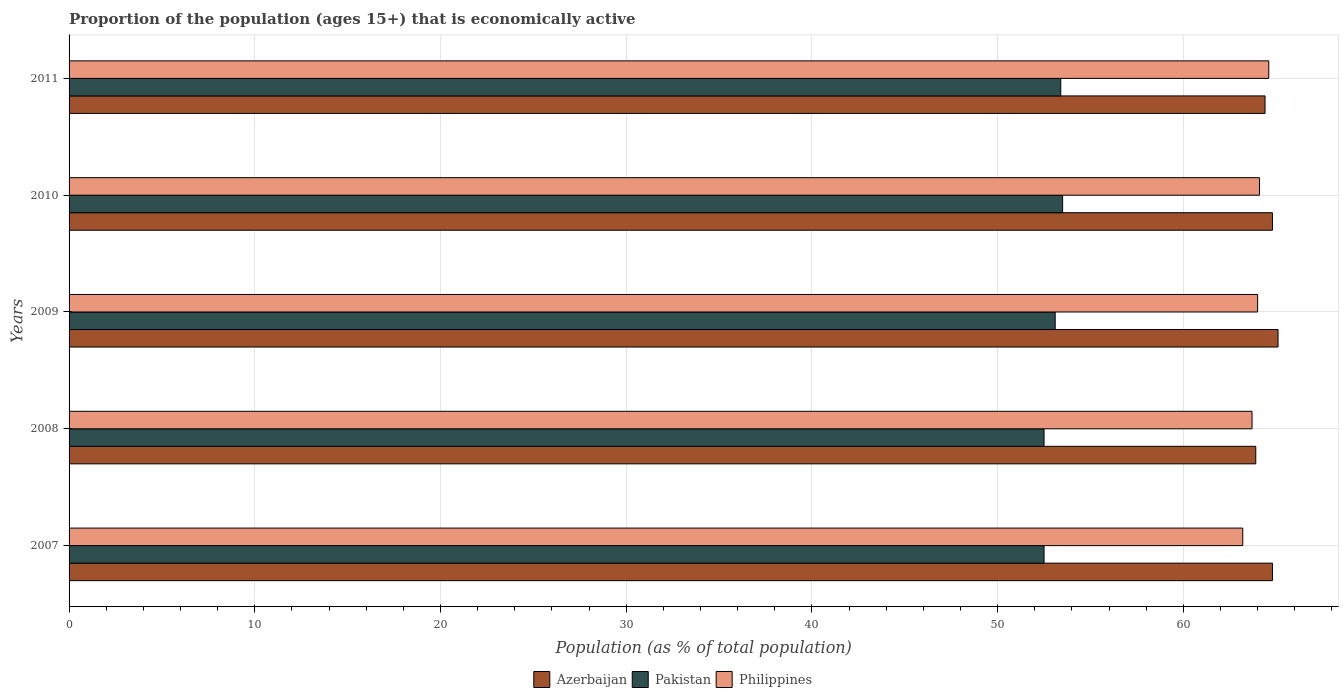How many bars are there on the 1st tick from the bottom?
Ensure brevity in your answer.  3. What is the label of the 3rd group of bars from the top?
Give a very brief answer. 2009. In how many cases, is the number of bars for a given year not equal to the number of legend labels?
Your response must be concise. 0. What is the proportion of the population that is economically active in Azerbaijan in 2009?
Offer a very short reply. 65.1. Across all years, what is the maximum proportion of the population that is economically active in Philippines?
Your response must be concise. 64.6. Across all years, what is the minimum proportion of the population that is economically active in Philippines?
Provide a succinct answer. 63.2. In which year was the proportion of the population that is economically active in Pakistan maximum?
Give a very brief answer. 2010. What is the total proportion of the population that is economically active in Philippines in the graph?
Offer a terse response. 319.6. What is the difference between the proportion of the population that is economically active in Azerbaijan in 2007 and that in 2008?
Offer a terse response. 0.9. What is the difference between the proportion of the population that is economically active in Pakistan in 2010 and the proportion of the population that is economically active in Azerbaijan in 2009?
Your answer should be very brief. -11.6. What is the average proportion of the population that is economically active in Azerbaijan per year?
Your answer should be very brief. 64.6. In the year 2011, what is the difference between the proportion of the population that is economically active in Philippines and proportion of the population that is economically active in Pakistan?
Make the answer very short. 11.2. What is the ratio of the proportion of the population that is economically active in Philippines in 2007 to that in 2008?
Your answer should be compact. 0.99. Is the difference between the proportion of the population that is economically active in Philippines in 2007 and 2008 greater than the difference between the proportion of the population that is economically active in Pakistan in 2007 and 2008?
Your response must be concise. No. What is the difference between the highest and the second highest proportion of the population that is economically active in Azerbaijan?
Your answer should be very brief. 0.3. What is the difference between the highest and the lowest proportion of the population that is economically active in Azerbaijan?
Your answer should be very brief. 1.2. Is the sum of the proportion of the population that is economically active in Azerbaijan in 2008 and 2009 greater than the maximum proportion of the population that is economically active in Philippines across all years?
Give a very brief answer. Yes. What does the 2nd bar from the bottom in 2009 represents?
Your response must be concise. Pakistan. Are all the bars in the graph horizontal?
Your answer should be very brief. Yes. How many years are there in the graph?
Your answer should be very brief. 5. How many legend labels are there?
Provide a succinct answer. 3. How are the legend labels stacked?
Provide a succinct answer. Horizontal. What is the title of the graph?
Provide a short and direct response. Proportion of the population (ages 15+) that is economically active. What is the label or title of the X-axis?
Provide a short and direct response. Population (as % of total population). What is the Population (as % of total population) of Azerbaijan in 2007?
Offer a very short reply. 64.8. What is the Population (as % of total population) of Pakistan in 2007?
Your answer should be very brief. 52.5. What is the Population (as % of total population) in Philippines in 2007?
Your answer should be very brief. 63.2. What is the Population (as % of total population) of Azerbaijan in 2008?
Provide a succinct answer. 63.9. What is the Population (as % of total population) in Pakistan in 2008?
Provide a succinct answer. 52.5. What is the Population (as % of total population) in Philippines in 2008?
Provide a succinct answer. 63.7. What is the Population (as % of total population) in Azerbaijan in 2009?
Your response must be concise. 65.1. What is the Population (as % of total population) in Pakistan in 2009?
Provide a short and direct response. 53.1. What is the Population (as % of total population) in Azerbaijan in 2010?
Offer a terse response. 64.8. What is the Population (as % of total population) of Pakistan in 2010?
Ensure brevity in your answer.  53.5. What is the Population (as % of total population) in Philippines in 2010?
Offer a terse response. 64.1. What is the Population (as % of total population) in Azerbaijan in 2011?
Your answer should be compact. 64.4. What is the Population (as % of total population) in Pakistan in 2011?
Your answer should be compact. 53.4. What is the Population (as % of total population) of Philippines in 2011?
Provide a succinct answer. 64.6. Across all years, what is the maximum Population (as % of total population) of Azerbaijan?
Offer a very short reply. 65.1. Across all years, what is the maximum Population (as % of total population) of Pakistan?
Your answer should be compact. 53.5. Across all years, what is the maximum Population (as % of total population) of Philippines?
Offer a terse response. 64.6. Across all years, what is the minimum Population (as % of total population) in Azerbaijan?
Provide a short and direct response. 63.9. Across all years, what is the minimum Population (as % of total population) of Pakistan?
Make the answer very short. 52.5. Across all years, what is the minimum Population (as % of total population) of Philippines?
Your answer should be very brief. 63.2. What is the total Population (as % of total population) in Azerbaijan in the graph?
Your answer should be very brief. 323. What is the total Population (as % of total population) in Pakistan in the graph?
Offer a terse response. 265. What is the total Population (as % of total population) of Philippines in the graph?
Your answer should be very brief. 319.6. What is the difference between the Population (as % of total population) in Pakistan in 2007 and that in 2008?
Provide a short and direct response. 0. What is the difference between the Population (as % of total population) of Philippines in 2007 and that in 2008?
Provide a short and direct response. -0.5. What is the difference between the Population (as % of total population) of Pakistan in 2007 and that in 2009?
Provide a short and direct response. -0.6. What is the difference between the Population (as % of total population) in Azerbaijan in 2007 and that in 2010?
Your response must be concise. 0. What is the difference between the Population (as % of total population) in Azerbaijan in 2007 and that in 2011?
Make the answer very short. 0.4. What is the difference between the Population (as % of total population) in Azerbaijan in 2008 and that in 2009?
Make the answer very short. -1.2. What is the difference between the Population (as % of total population) of Philippines in 2008 and that in 2009?
Ensure brevity in your answer.  -0.3. What is the difference between the Population (as % of total population) of Pakistan in 2008 and that in 2010?
Offer a terse response. -1. What is the difference between the Population (as % of total population) of Philippines in 2008 and that in 2010?
Provide a succinct answer. -0.4. What is the difference between the Population (as % of total population) in Azerbaijan in 2008 and that in 2011?
Offer a very short reply. -0.5. What is the difference between the Population (as % of total population) of Azerbaijan in 2009 and that in 2010?
Offer a terse response. 0.3. What is the difference between the Population (as % of total population) in Pakistan in 2009 and that in 2010?
Offer a very short reply. -0.4. What is the difference between the Population (as % of total population) in Philippines in 2009 and that in 2011?
Ensure brevity in your answer.  -0.6. What is the difference between the Population (as % of total population) in Philippines in 2010 and that in 2011?
Make the answer very short. -0.5. What is the difference between the Population (as % of total population) in Azerbaijan in 2007 and the Population (as % of total population) in Pakistan in 2008?
Offer a terse response. 12.3. What is the difference between the Population (as % of total population) of Azerbaijan in 2007 and the Population (as % of total population) of Philippines in 2009?
Your answer should be compact. 0.8. What is the difference between the Population (as % of total population) of Pakistan in 2007 and the Population (as % of total population) of Philippines in 2009?
Your answer should be very brief. -11.5. What is the difference between the Population (as % of total population) in Azerbaijan in 2007 and the Population (as % of total population) in Pakistan in 2010?
Your answer should be very brief. 11.3. What is the difference between the Population (as % of total population) in Azerbaijan in 2007 and the Population (as % of total population) in Philippines in 2010?
Your answer should be compact. 0.7. What is the difference between the Population (as % of total population) in Azerbaijan in 2008 and the Population (as % of total population) in Pakistan in 2009?
Your answer should be compact. 10.8. What is the difference between the Population (as % of total population) in Pakistan in 2008 and the Population (as % of total population) in Philippines in 2009?
Keep it short and to the point. -11.5. What is the difference between the Population (as % of total population) of Azerbaijan in 2008 and the Population (as % of total population) of Pakistan in 2011?
Make the answer very short. 10.5. What is the difference between the Population (as % of total population) in Azerbaijan in 2009 and the Population (as % of total population) in Philippines in 2010?
Make the answer very short. 1. What is the difference between the Population (as % of total population) of Azerbaijan in 2009 and the Population (as % of total population) of Pakistan in 2011?
Keep it short and to the point. 11.7. What is the difference between the Population (as % of total population) in Azerbaijan in 2009 and the Population (as % of total population) in Philippines in 2011?
Give a very brief answer. 0.5. What is the difference between the Population (as % of total population) in Pakistan in 2009 and the Population (as % of total population) in Philippines in 2011?
Give a very brief answer. -11.5. What is the difference between the Population (as % of total population) in Azerbaijan in 2010 and the Population (as % of total population) in Pakistan in 2011?
Your answer should be very brief. 11.4. What is the difference between the Population (as % of total population) of Azerbaijan in 2010 and the Population (as % of total population) of Philippines in 2011?
Give a very brief answer. 0.2. What is the difference between the Population (as % of total population) in Pakistan in 2010 and the Population (as % of total population) in Philippines in 2011?
Your answer should be compact. -11.1. What is the average Population (as % of total population) of Azerbaijan per year?
Ensure brevity in your answer.  64.6. What is the average Population (as % of total population) of Pakistan per year?
Your answer should be compact. 53. What is the average Population (as % of total population) of Philippines per year?
Ensure brevity in your answer.  63.92. In the year 2007, what is the difference between the Population (as % of total population) of Pakistan and Population (as % of total population) of Philippines?
Your response must be concise. -10.7. In the year 2008, what is the difference between the Population (as % of total population) in Azerbaijan and Population (as % of total population) in Philippines?
Give a very brief answer. 0.2. In the year 2009, what is the difference between the Population (as % of total population) of Azerbaijan and Population (as % of total population) of Pakistan?
Make the answer very short. 12. In the year 2009, what is the difference between the Population (as % of total population) in Azerbaijan and Population (as % of total population) in Philippines?
Give a very brief answer. 1.1. In the year 2010, what is the difference between the Population (as % of total population) of Azerbaijan and Population (as % of total population) of Philippines?
Ensure brevity in your answer.  0.7. In the year 2010, what is the difference between the Population (as % of total population) of Pakistan and Population (as % of total population) of Philippines?
Your response must be concise. -10.6. In the year 2011, what is the difference between the Population (as % of total population) of Azerbaijan and Population (as % of total population) of Pakistan?
Your answer should be compact. 11. In the year 2011, what is the difference between the Population (as % of total population) of Azerbaijan and Population (as % of total population) of Philippines?
Make the answer very short. -0.2. In the year 2011, what is the difference between the Population (as % of total population) of Pakistan and Population (as % of total population) of Philippines?
Keep it short and to the point. -11.2. What is the ratio of the Population (as % of total population) of Azerbaijan in 2007 to that in 2008?
Make the answer very short. 1.01. What is the ratio of the Population (as % of total population) in Philippines in 2007 to that in 2008?
Provide a succinct answer. 0.99. What is the ratio of the Population (as % of total population) of Azerbaijan in 2007 to that in 2009?
Offer a very short reply. 1. What is the ratio of the Population (as % of total population) in Pakistan in 2007 to that in 2009?
Keep it short and to the point. 0.99. What is the ratio of the Population (as % of total population) of Philippines in 2007 to that in 2009?
Offer a terse response. 0.99. What is the ratio of the Population (as % of total population) in Azerbaijan in 2007 to that in 2010?
Provide a short and direct response. 1. What is the ratio of the Population (as % of total population) in Pakistan in 2007 to that in 2010?
Ensure brevity in your answer.  0.98. What is the ratio of the Population (as % of total population) in Philippines in 2007 to that in 2010?
Ensure brevity in your answer.  0.99. What is the ratio of the Population (as % of total population) in Pakistan in 2007 to that in 2011?
Your answer should be compact. 0.98. What is the ratio of the Population (as % of total population) of Philippines in 2007 to that in 2011?
Provide a short and direct response. 0.98. What is the ratio of the Population (as % of total population) in Azerbaijan in 2008 to that in 2009?
Keep it short and to the point. 0.98. What is the ratio of the Population (as % of total population) in Pakistan in 2008 to that in 2009?
Offer a very short reply. 0.99. What is the ratio of the Population (as % of total population) of Azerbaijan in 2008 to that in 2010?
Give a very brief answer. 0.99. What is the ratio of the Population (as % of total population) of Pakistan in 2008 to that in 2010?
Your answer should be very brief. 0.98. What is the ratio of the Population (as % of total population) in Azerbaijan in 2008 to that in 2011?
Keep it short and to the point. 0.99. What is the ratio of the Population (as % of total population) in Pakistan in 2008 to that in 2011?
Offer a terse response. 0.98. What is the ratio of the Population (as % of total population) of Philippines in 2008 to that in 2011?
Ensure brevity in your answer.  0.99. What is the ratio of the Population (as % of total population) in Azerbaijan in 2009 to that in 2010?
Provide a succinct answer. 1. What is the ratio of the Population (as % of total population) of Pakistan in 2009 to that in 2010?
Your answer should be very brief. 0.99. What is the ratio of the Population (as % of total population) of Azerbaijan in 2009 to that in 2011?
Give a very brief answer. 1.01. What is the ratio of the Population (as % of total population) in Philippines in 2009 to that in 2011?
Provide a short and direct response. 0.99. What is the ratio of the Population (as % of total population) of Philippines in 2010 to that in 2011?
Your answer should be compact. 0.99. What is the difference between the highest and the lowest Population (as % of total population) of Azerbaijan?
Give a very brief answer. 1.2. What is the difference between the highest and the lowest Population (as % of total population) of Pakistan?
Make the answer very short. 1. 